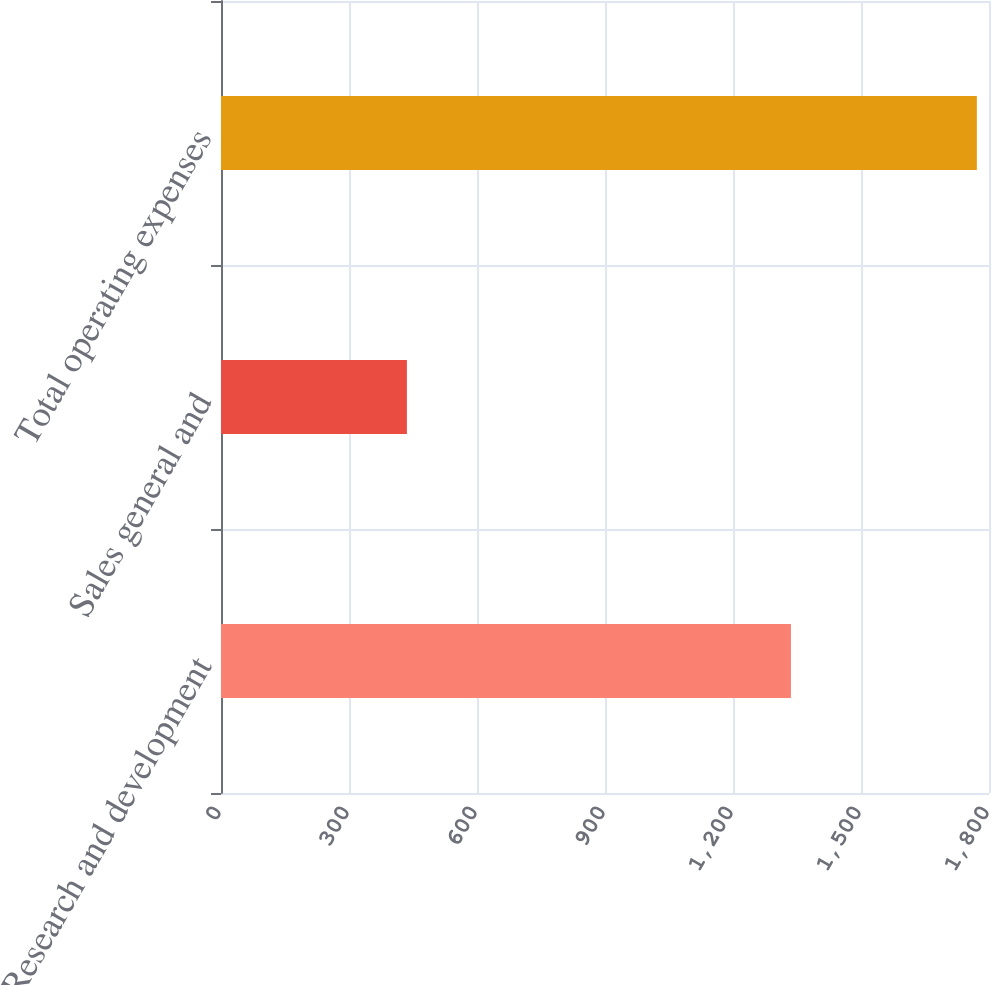Convert chart. <chart><loc_0><loc_0><loc_500><loc_500><bar_chart><fcel>Research and development<fcel>Sales general and<fcel>Total operating expenses<nl><fcel>1335.8<fcel>435.7<fcel>1771.5<nl></chart> 